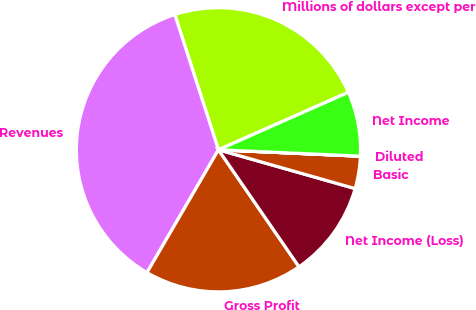<chart> <loc_0><loc_0><loc_500><loc_500><pie_chart><fcel>Millions of dollars except per<fcel>Revenues<fcel>Gross Profit<fcel>Net Income (Loss)<fcel>Basic<fcel>Diluted<fcel>Net Income<nl><fcel>23.34%<fcel>36.64%<fcel>17.98%<fcel>11.0%<fcel>3.68%<fcel>0.01%<fcel>7.34%<nl></chart> 